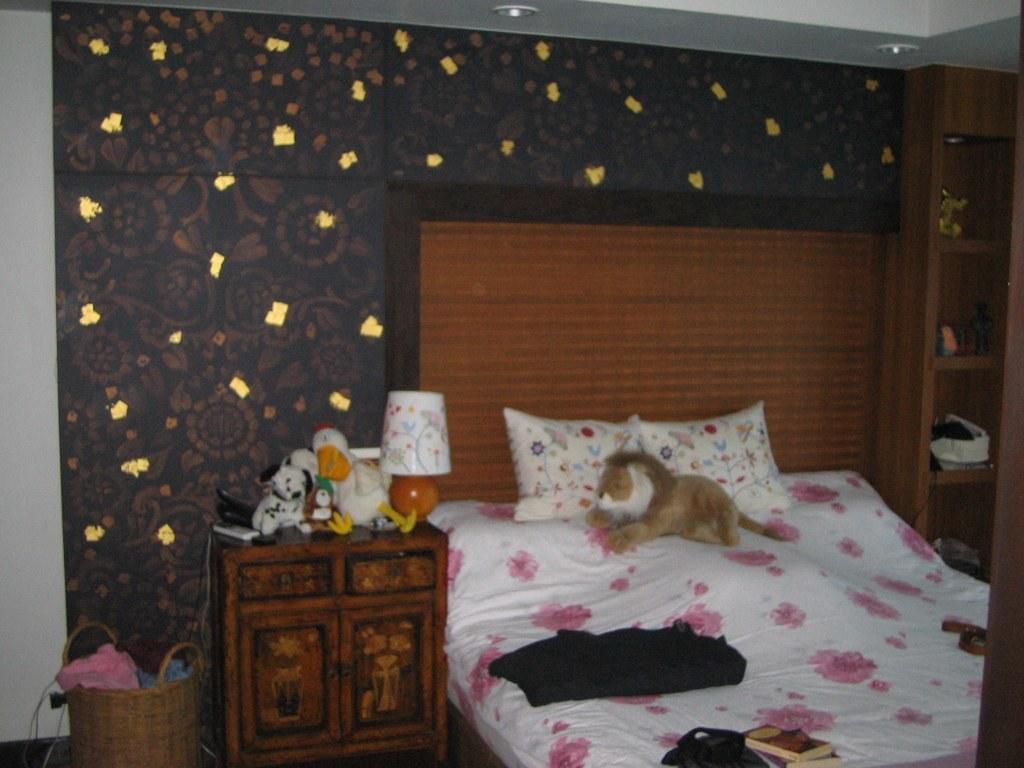Could you give a brief overview of what you see in this image? In the image we can see there is a bed on which there are toys and a bag kept on it and on table there are toys and a table lamp. 